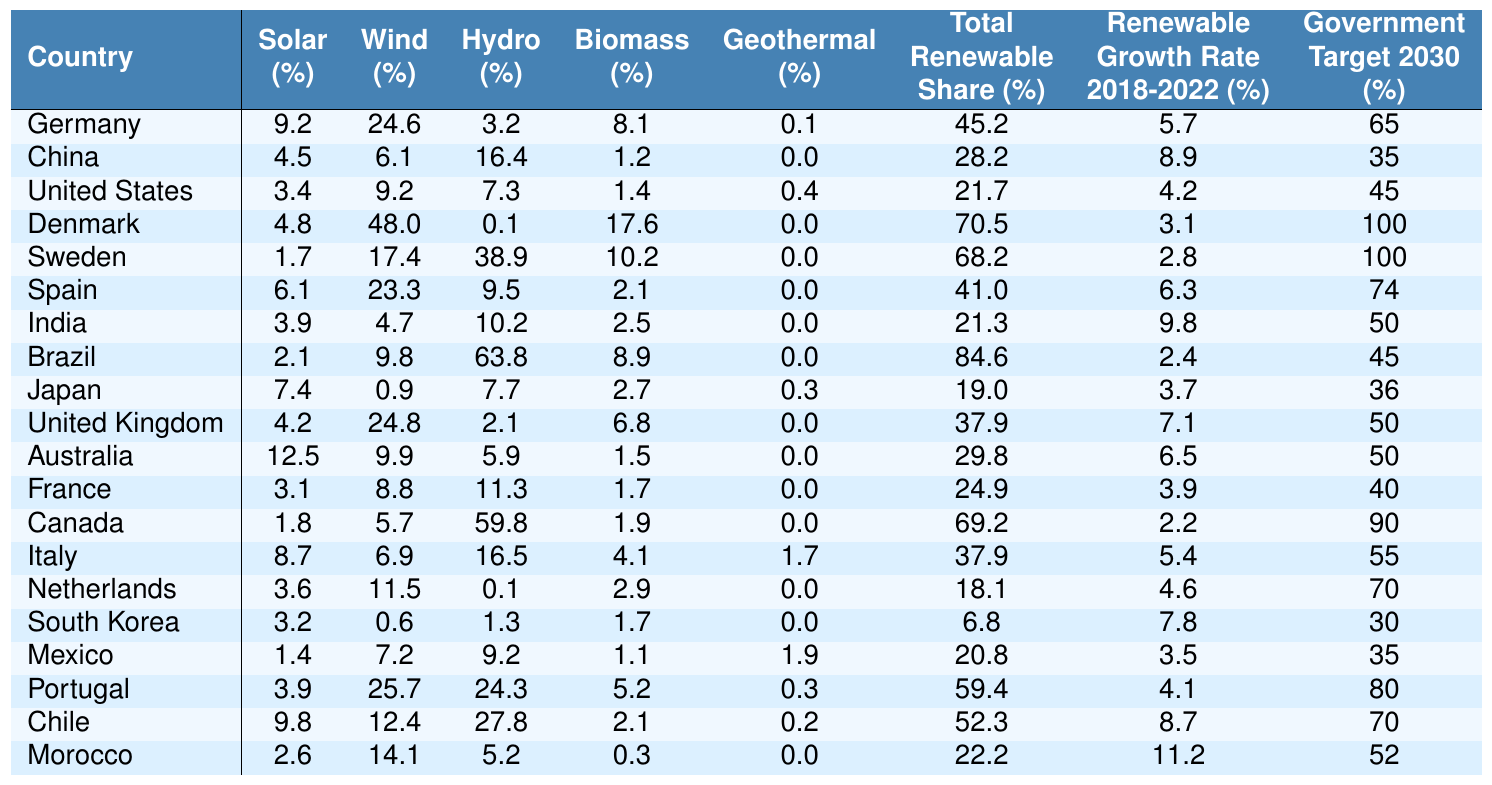What is the solar adoption rate in Germany? The solar adoption rate for Germany is listed directly in the table, which shows the value as 9.2%.
Answer: 9.2% Which country has the highest wind adoption rate? By scanning the wind adoption rate column, Denmark has the highest value at 48%.
Answer: Denmark What is the average hydro adoption rate across all countries? To calculate the average, sum all hydro adoption rates (3.2 + 16.4 + 7.3 + 0.1 + 38.9 + 9.5 + 10.2 + 63.8 + 7.7 + 2.1 + 5.9 + 11.3 + 59.8 + 16.5 + 0.1 + 1.3 + 9.2 + 24.3 + 27.8 + 5.2 = 321.8), then divide by the total countries (20), resulting in 321.8 / 20 = 16.09%.
Answer: 16.09% What is the total renewable share for Brazil? The table shows Brazil's total renewable share as 84.6%.
Answer: 84.6% Did Morocco meet its government renewable target of 52%? By checking Morocco's government renewable target in the final column against its total renewable share, which is 22.2%, it does not meet the target as 22.2% is less than 52%.
Answer: No Which country has the highest total renewable share and what is that share? By reviewing the total renewable share column, Brazil has the highest share at 84.6%.
Answer: Brazil, 84.6% What is the difference in the wind adoption rates between Germany and China? Germany's wind adoption rate is 24.6%, while China's is 6.1%. The difference can be calculated as 24.6 - 6.1 = 18.5%.
Answer: 18.5% Which countries have a geothermal adoption rate greater than 1%? By examining the geothermal adoption rate column, only Italy and Portugal have rates greater than 1% (1.7% and 0.3%, respectively), and verifying other entries confirms no other countries meet this criterion.
Answer: Italy, Portugal What is the lowest biomass adoption rate among the listed countries? The biomass adoption rates are compared with the lowest being 0.3% for Morocco, which is noted in the table.
Answer: 0.3% If you combine the solar adoption rates for Germany and Sweden, what is the sum? Germany has a solar adoption rate of 9.2% and Sweden has 1.7%. The sum is calculated as 9.2 + 1.7 = 10.9%.
Answer: 10.9% 